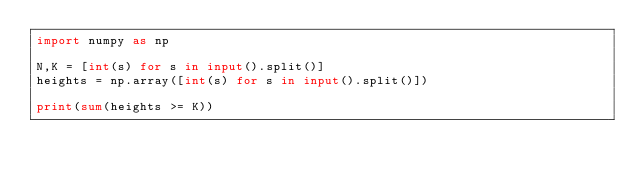<code> <loc_0><loc_0><loc_500><loc_500><_Python_>import numpy as np
 
N,K = [int(s) for s in input().split()]
heights = np.array([int(s) for s in input().split()])
 
print(sum(heights >= K))</code> 